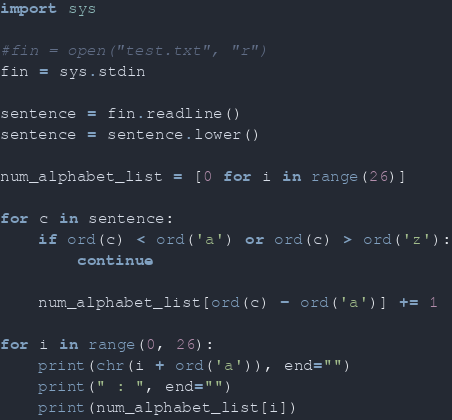<code> <loc_0><loc_0><loc_500><loc_500><_Python_>import sys

#fin = open("test.txt", "r")
fin = sys.stdin

sentence = fin.readline()
sentence = sentence.lower()

num_alphabet_list = [0 for i in range(26)]

for c in sentence:
	if ord(c) < ord('a') or ord(c) > ord('z'):
		continue

	num_alphabet_list[ord(c) - ord('a')] += 1

for i in range(0, 26):
	print(chr(i + ord('a')), end="")
	print(" : ", end="")
	print(num_alphabet_list[i])</code> 